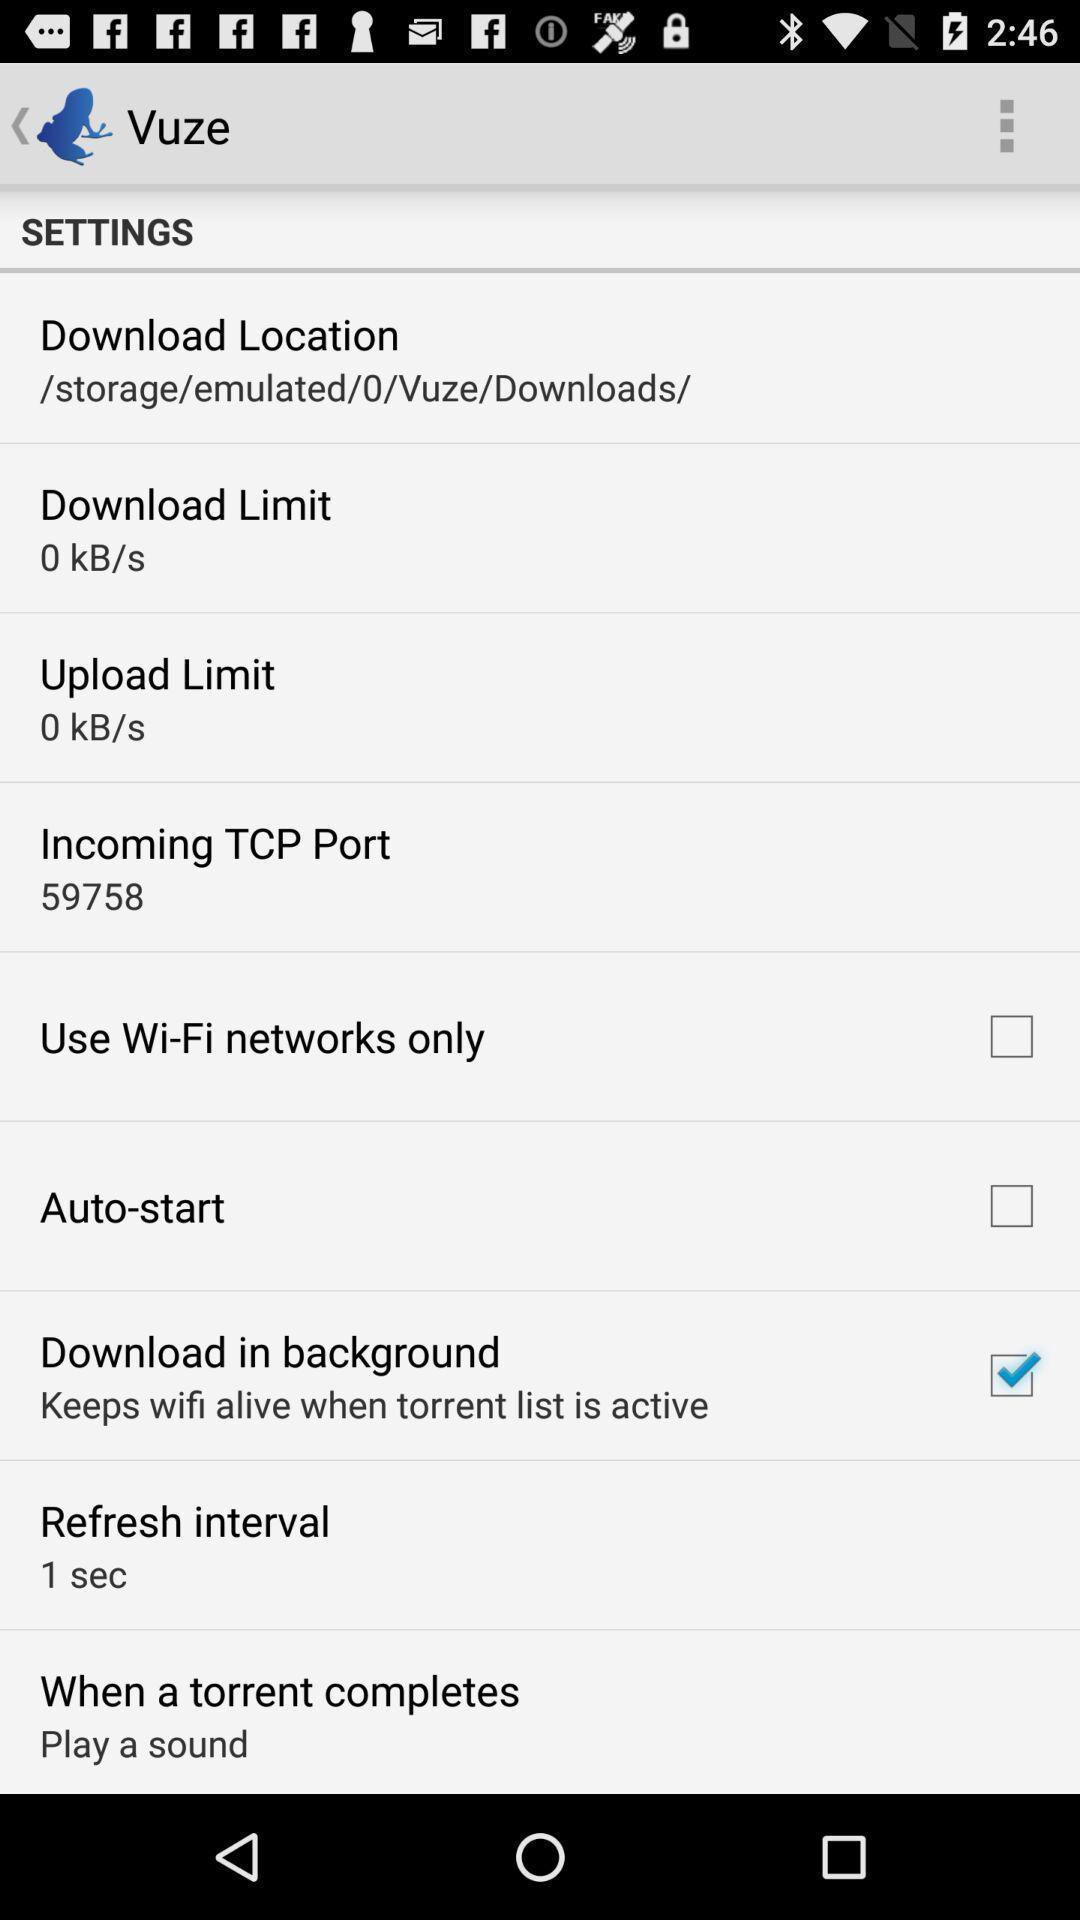What details can you identify in this image? Settings page with different options. 